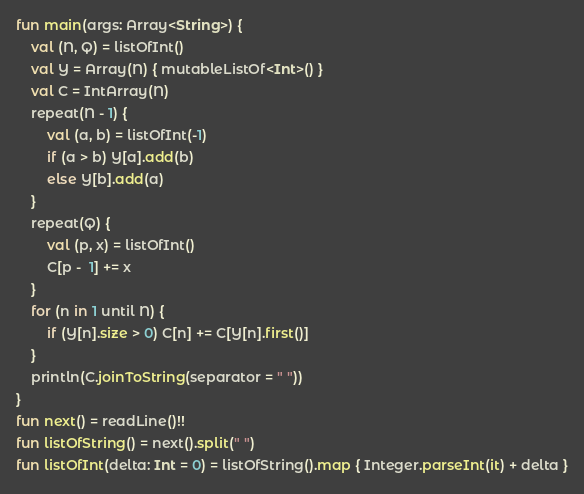<code> <loc_0><loc_0><loc_500><loc_500><_Kotlin_>fun main(args: Array<String>) {
    val (N, Q) = listOfInt()
    val Y = Array(N) { mutableListOf<Int>() }
    val C = IntArray(N)
    repeat(N - 1) {
        val (a, b) = listOfInt(-1)
        if (a > b) Y[a].add(b)
        else Y[b].add(a)
    }
    repeat(Q) {
        val (p, x) = listOfInt()
        C[p -  1] += x
    }
    for (n in 1 until N) {
        if (Y[n].size > 0) C[n] += C[Y[n].first()]
    }
    println(C.joinToString(separator = " "))
}
fun next() = readLine()!!
fun listOfString() = next().split(" ")
fun listOfInt(delta: Int = 0) = listOfString().map { Integer.parseInt(it) + delta }
</code> 